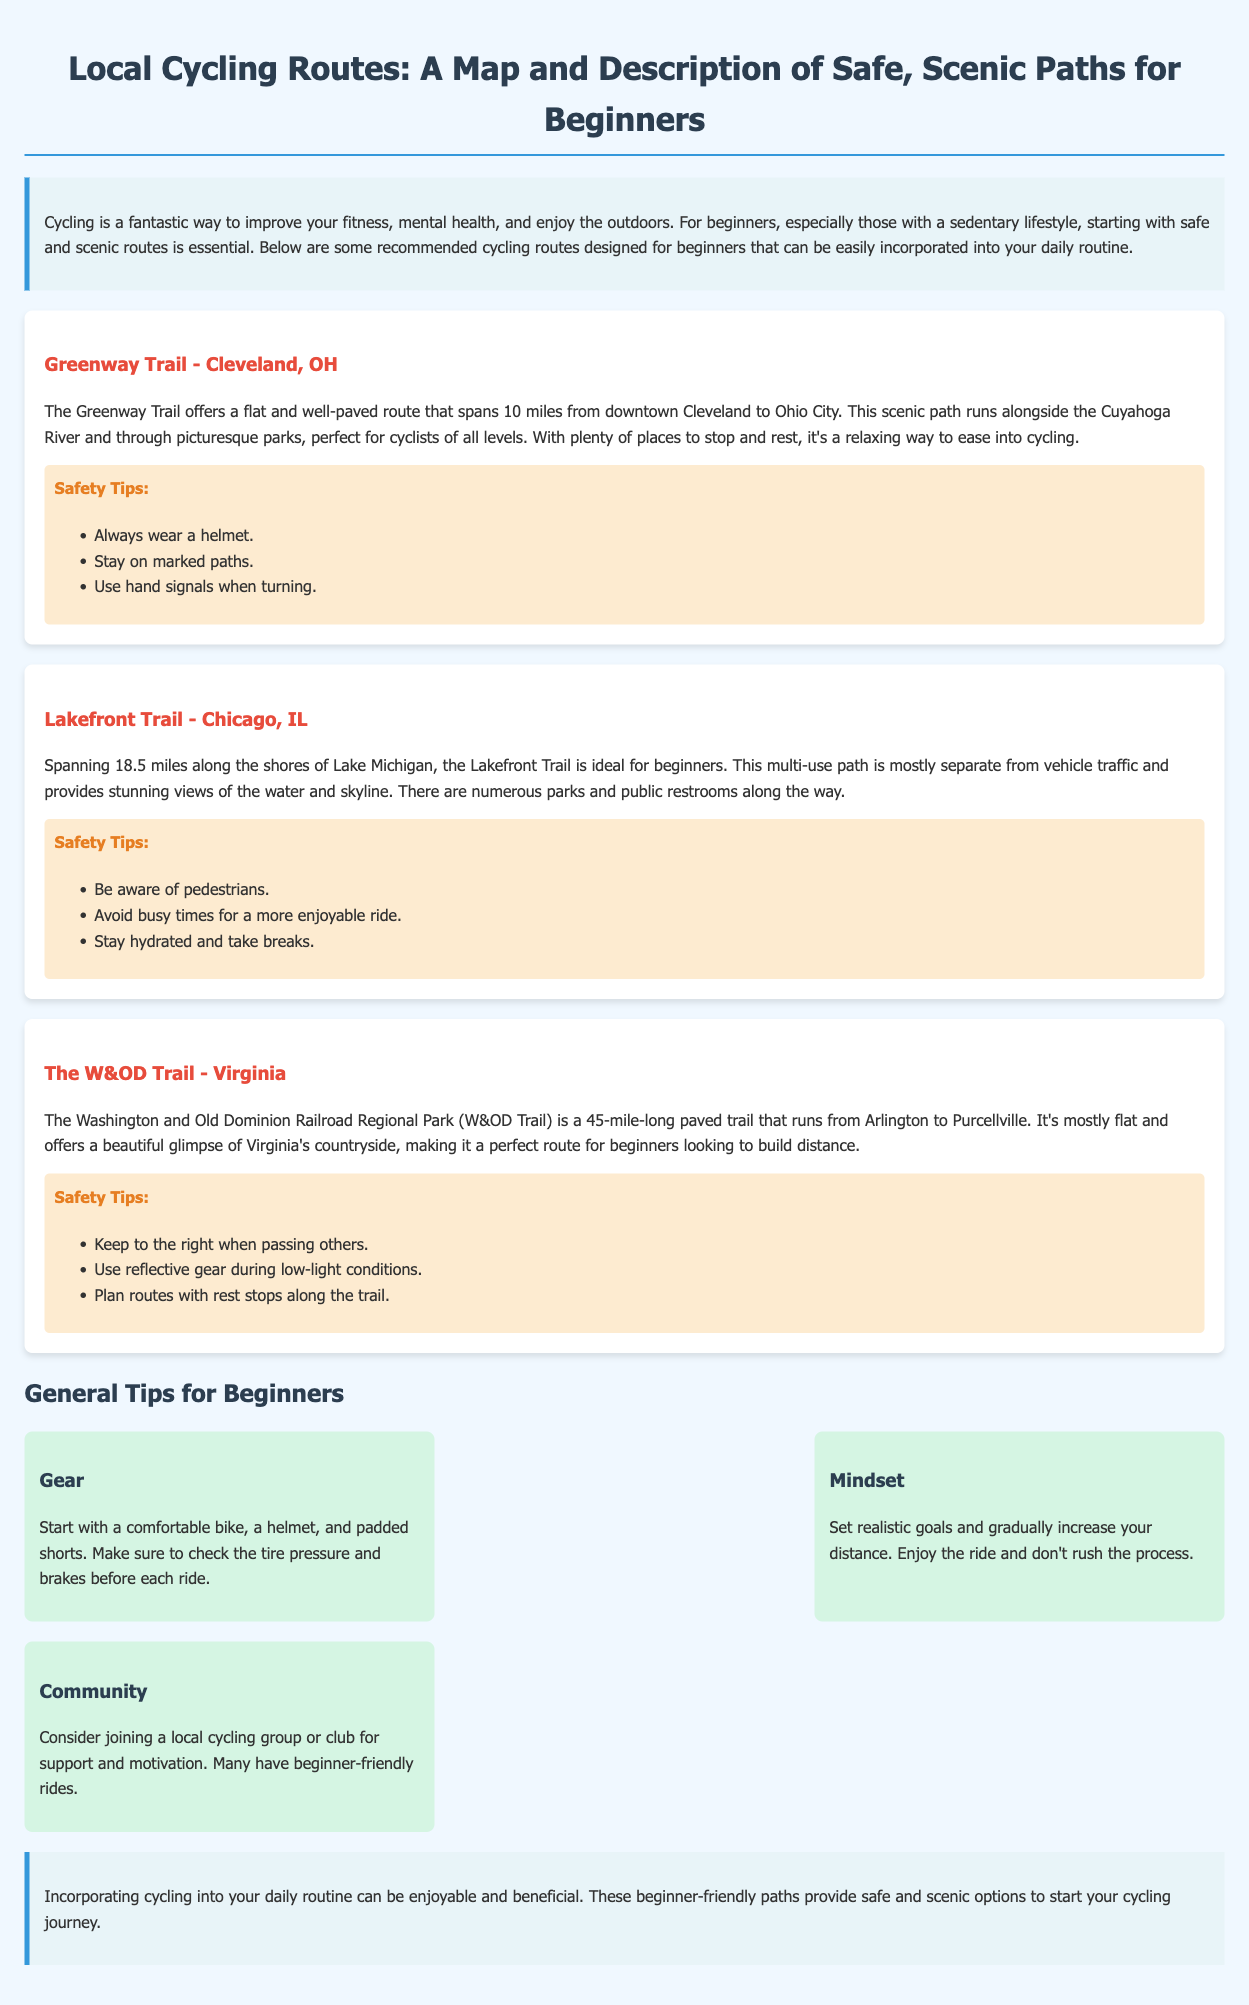What is the length of the Greenway Trail? The Greenway Trail spans 10 miles.
Answer: 10 miles What is a key safety tip for the Lakefront Trail? A key safety tip is to be aware of pedestrians.
Answer: Be aware of pedestrians What is the main feature of The W&OD Trail? The W&OD Trail is mostly flat and offers scenic views of Virginia's countryside.
Answer: Mostly flat and scenic views How many miles does the Lakefront Trail cover? The Lakefront Trail covers 18.5 miles along the shores of Lake Michigan.
Answer: 18.5 miles What should beginners consider joining for support? Beginners should consider joining a local cycling group or club.
Answer: A local cycling group or club What type of bike is recommended to start with? It is recommended to start with a comfortable bike.
Answer: Comfortable bike What is one aspect beginners should focus on regarding their mindset? Beginners should set realistic goals and gradually increase their distance.
Answer: Set realistic goals What is the total length of The W&OD Trail? The W&OD Trail is 45 miles long.
Answer: 45 miles What common feature do all recommended routes provide? All recommended routes provide scenic paths that are safe for beginners.
Answer: Scenic paths that are safe for beginners 